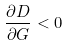Convert formula to latex. <formula><loc_0><loc_0><loc_500><loc_500>\frac { \partial D } { \partial G } < 0</formula> 